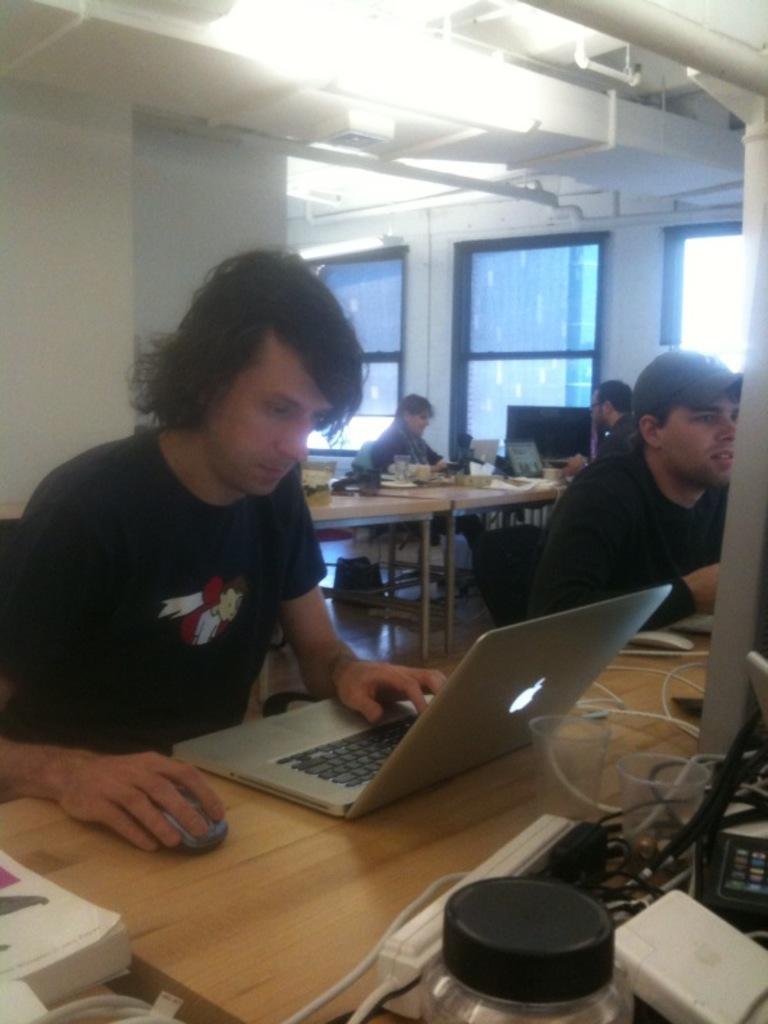Could you give a brief overview of what you see in this image? There is a group of people. They are sitting on a chair. There is a table. There is a laptop and battery on a table. We can see in the background there is a window and pillar. 